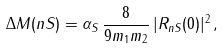<formula> <loc_0><loc_0><loc_500><loc_500>\Delta M ( n S ) = \alpha _ { S } \, \frac { 8 } { 9 m _ { 1 } m _ { 2 } } \, | R _ { n S } ( 0 ) | ^ { 2 } \, ,</formula> 